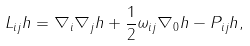Convert formula to latex. <formula><loc_0><loc_0><loc_500><loc_500>L _ { i j } h = \nabla _ { i } \nabla _ { j } h + \frac { 1 } { 2 } \omega _ { i j } \nabla _ { 0 } h - P _ { i j } h ,</formula> 